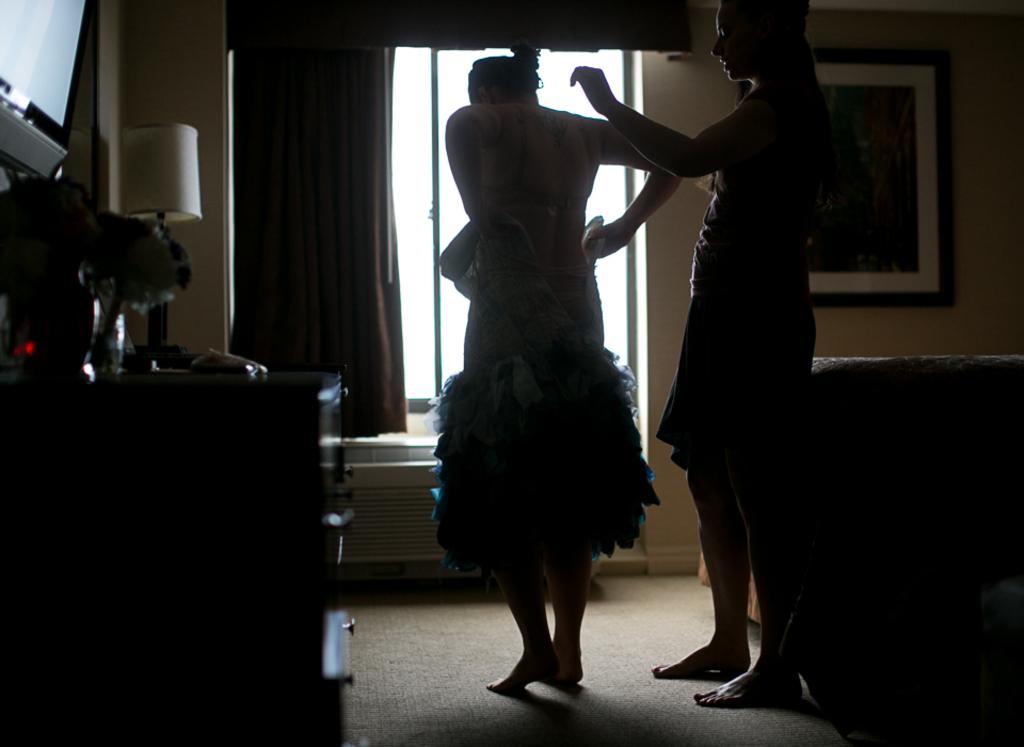In one or two sentences, can you explain what this image depicts? In this picture there are two women standing and there is a sofa in the right corner and there is a table which has few objects placed on it in the left corner and there is a photo frame attached to the wall and there is a window and a curtain in the background. 